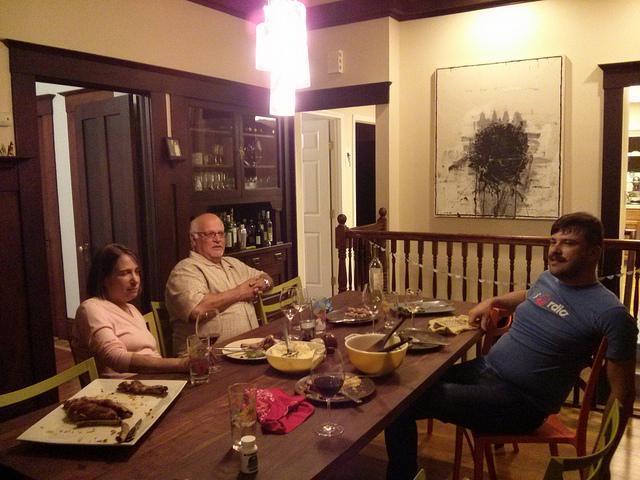How many people are in this picture?
Give a very brief answer. 3. How many of the diners are overweight?
Give a very brief answer. 3. How many people are in the picture?
Give a very brief answer. 3. How many chairs are in the picture?
Give a very brief answer. 2. 